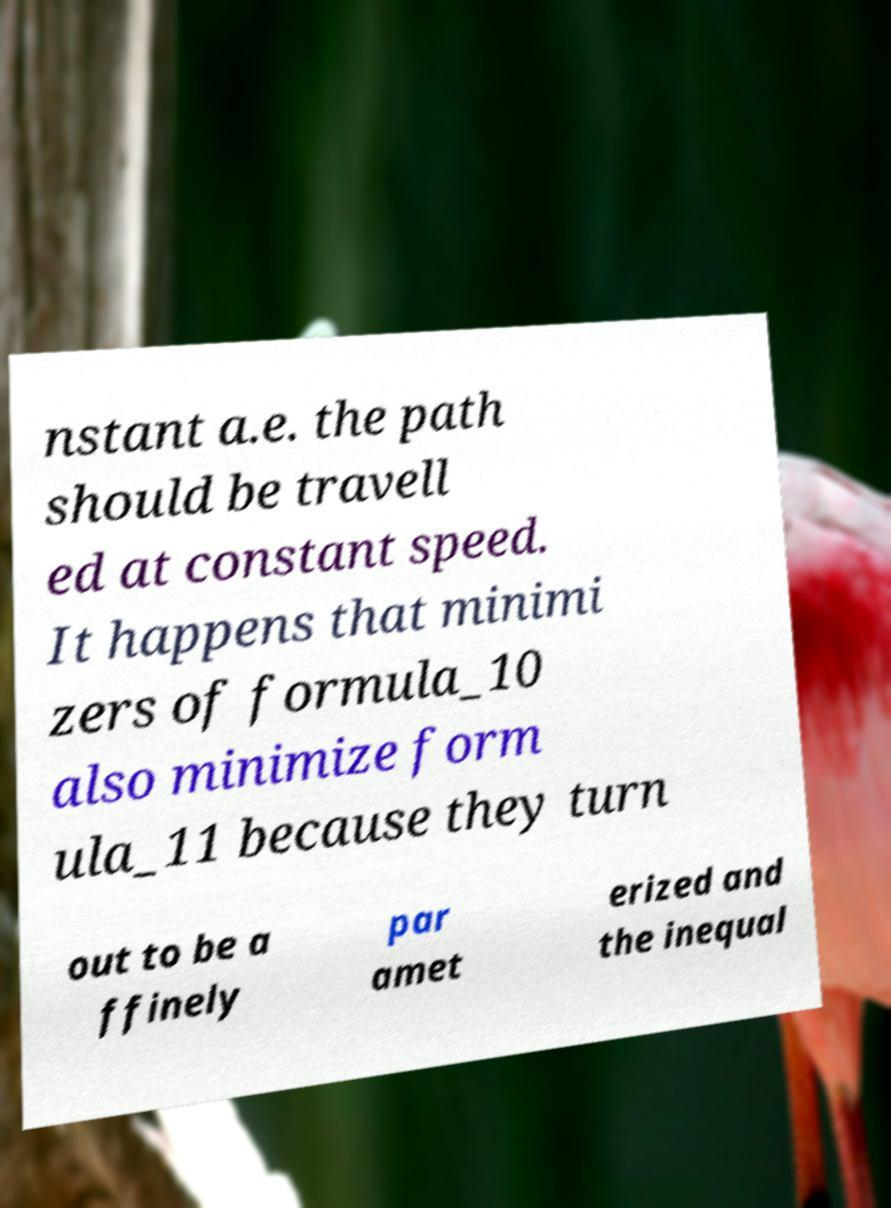Could you extract and type out the text from this image? nstant a.e. the path should be travell ed at constant speed. It happens that minimi zers of formula_10 also minimize form ula_11 because they turn out to be a ffinely par amet erized and the inequal 